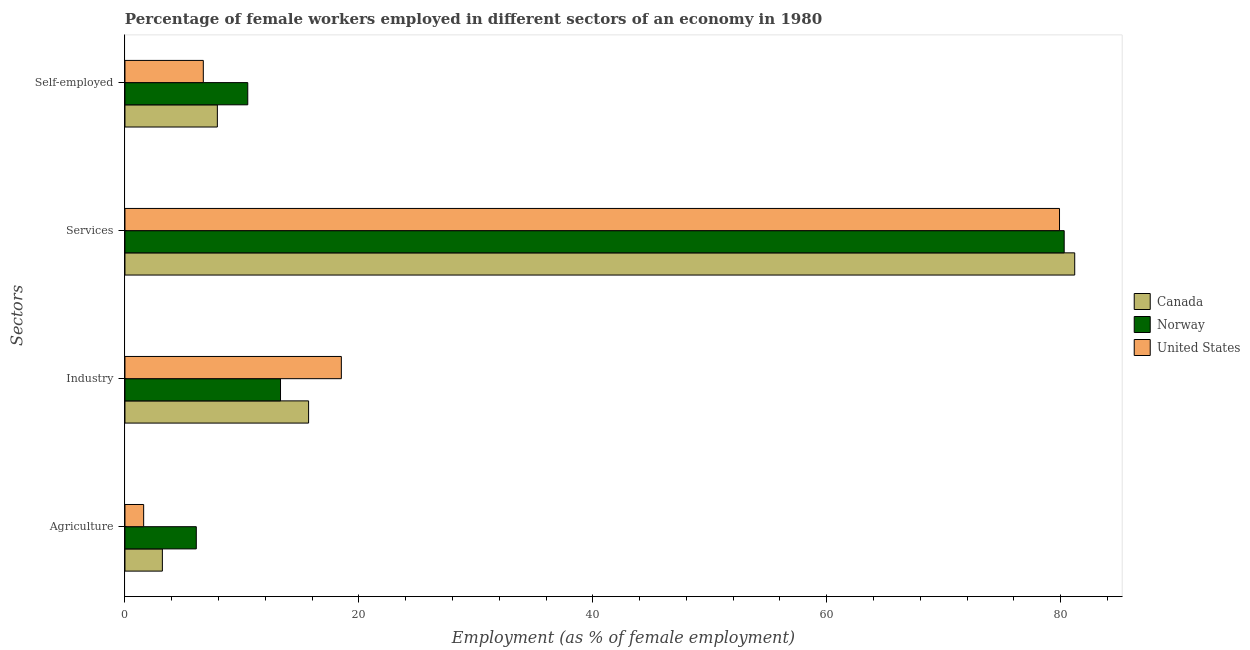How many groups of bars are there?
Offer a terse response. 4. Are the number of bars on each tick of the Y-axis equal?
Provide a short and direct response. Yes. How many bars are there on the 4th tick from the bottom?
Keep it short and to the point. 3. What is the label of the 1st group of bars from the top?
Your answer should be compact. Self-employed. What is the percentage of female workers in services in Canada?
Your response must be concise. 81.2. Across all countries, what is the minimum percentage of female workers in services?
Make the answer very short. 79.9. In which country was the percentage of female workers in industry minimum?
Give a very brief answer. Norway. What is the total percentage of female workers in services in the graph?
Your answer should be compact. 241.4. What is the difference between the percentage of female workers in industry in Canada and that in Norway?
Provide a short and direct response. 2.4. What is the difference between the percentage of self employed female workers in United States and the percentage of female workers in agriculture in Canada?
Offer a terse response. 3.5. What is the average percentage of female workers in industry per country?
Keep it short and to the point. 15.83. What is the difference between the percentage of female workers in industry and percentage of female workers in agriculture in Norway?
Keep it short and to the point. 7.2. In how many countries, is the percentage of female workers in services greater than 64 %?
Your answer should be compact. 3. What is the ratio of the percentage of self employed female workers in United States to that in Norway?
Keep it short and to the point. 0.64. Is the percentage of female workers in industry in Norway less than that in Canada?
Your answer should be compact. Yes. Is the difference between the percentage of female workers in services in United States and Canada greater than the difference between the percentage of female workers in industry in United States and Canada?
Offer a very short reply. No. What is the difference between the highest and the second highest percentage of female workers in agriculture?
Provide a succinct answer. 2.9. What is the difference between the highest and the lowest percentage of female workers in industry?
Make the answer very short. 5.2. What does the 2nd bar from the top in Services represents?
Provide a short and direct response. Norway. What does the 2nd bar from the bottom in Self-employed represents?
Your response must be concise. Norway. How many countries are there in the graph?
Give a very brief answer. 3. Are the values on the major ticks of X-axis written in scientific E-notation?
Offer a very short reply. No. How many legend labels are there?
Give a very brief answer. 3. How are the legend labels stacked?
Give a very brief answer. Vertical. What is the title of the graph?
Your answer should be compact. Percentage of female workers employed in different sectors of an economy in 1980. What is the label or title of the X-axis?
Provide a succinct answer. Employment (as % of female employment). What is the label or title of the Y-axis?
Make the answer very short. Sectors. What is the Employment (as % of female employment) in Canada in Agriculture?
Offer a very short reply. 3.2. What is the Employment (as % of female employment) of Norway in Agriculture?
Keep it short and to the point. 6.1. What is the Employment (as % of female employment) of United States in Agriculture?
Give a very brief answer. 1.6. What is the Employment (as % of female employment) in Canada in Industry?
Your answer should be compact. 15.7. What is the Employment (as % of female employment) of Norway in Industry?
Your response must be concise. 13.3. What is the Employment (as % of female employment) in Canada in Services?
Offer a very short reply. 81.2. What is the Employment (as % of female employment) of Norway in Services?
Keep it short and to the point. 80.3. What is the Employment (as % of female employment) of United States in Services?
Offer a very short reply. 79.9. What is the Employment (as % of female employment) in Canada in Self-employed?
Provide a short and direct response. 7.9. What is the Employment (as % of female employment) in United States in Self-employed?
Provide a succinct answer. 6.7. Across all Sectors, what is the maximum Employment (as % of female employment) of Canada?
Your response must be concise. 81.2. Across all Sectors, what is the maximum Employment (as % of female employment) of Norway?
Give a very brief answer. 80.3. Across all Sectors, what is the maximum Employment (as % of female employment) in United States?
Your answer should be compact. 79.9. Across all Sectors, what is the minimum Employment (as % of female employment) in Canada?
Make the answer very short. 3.2. Across all Sectors, what is the minimum Employment (as % of female employment) in Norway?
Keep it short and to the point. 6.1. Across all Sectors, what is the minimum Employment (as % of female employment) of United States?
Your answer should be compact. 1.6. What is the total Employment (as % of female employment) in Canada in the graph?
Ensure brevity in your answer.  108. What is the total Employment (as % of female employment) of Norway in the graph?
Offer a very short reply. 110.2. What is the total Employment (as % of female employment) in United States in the graph?
Provide a succinct answer. 106.7. What is the difference between the Employment (as % of female employment) in Canada in Agriculture and that in Industry?
Keep it short and to the point. -12.5. What is the difference between the Employment (as % of female employment) in Norway in Agriculture and that in Industry?
Provide a succinct answer. -7.2. What is the difference between the Employment (as % of female employment) of United States in Agriculture and that in Industry?
Offer a very short reply. -16.9. What is the difference between the Employment (as % of female employment) of Canada in Agriculture and that in Services?
Your response must be concise. -78. What is the difference between the Employment (as % of female employment) of Norway in Agriculture and that in Services?
Provide a short and direct response. -74.2. What is the difference between the Employment (as % of female employment) of United States in Agriculture and that in Services?
Keep it short and to the point. -78.3. What is the difference between the Employment (as % of female employment) in Norway in Agriculture and that in Self-employed?
Ensure brevity in your answer.  -4.4. What is the difference between the Employment (as % of female employment) in United States in Agriculture and that in Self-employed?
Keep it short and to the point. -5.1. What is the difference between the Employment (as % of female employment) of Canada in Industry and that in Services?
Provide a short and direct response. -65.5. What is the difference between the Employment (as % of female employment) of Norway in Industry and that in Services?
Make the answer very short. -67. What is the difference between the Employment (as % of female employment) of United States in Industry and that in Services?
Give a very brief answer. -61.4. What is the difference between the Employment (as % of female employment) of Canada in Industry and that in Self-employed?
Offer a terse response. 7.8. What is the difference between the Employment (as % of female employment) in Canada in Services and that in Self-employed?
Make the answer very short. 73.3. What is the difference between the Employment (as % of female employment) in Norway in Services and that in Self-employed?
Your answer should be compact. 69.8. What is the difference between the Employment (as % of female employment) in United States in Services and that in Self-employed?
Provide a short and direct response. 73.2. What is the difference between the Employment (as % of female employment) of Canada in Agriculture and the Employment (as % of female employment) of United States in Industry?
Give a very brief answer. -15.3. What is the difference between the Employment (as % of female employment) in Norway in Agriculture and the Employment (as % of female employment) in United States in Industry?
Your answer should be very brief. -12.4. What is the difference between the Employment (as % of female employment) in Canada in Agriculture and the Employment (as % of female employment) in Norway in Services?
Keep it short and to the point. -77.1. What is the difference between the Employment (as % of female employment) of Canada in Agriculture and the Employment (as % of female employment) of United States in Services?
Ensure brevity in your answer.  -76.7. What is the difference between the Employment (as % of female employment) in Norway in Agriculture and the Employment (as % of female employment) in United States in Services?
Your answer should be very brief. -73.8. What is the difference between the Employment (as % of female employment) in Canada in Agriculture and the Employment (as % of female employment) in Norway in Self-employed?
Offer a very short reply. -7.3. What is the difference between the Employment (as % of female employment) in Canada in Industry and the Employment (as % of female employment) in Norway in Services?
Offer a very short reply. -64.6. What is the difference between the Employment (as % of female employment) in Canada in Industry and the Employment (as % of female employment) in United States in Services?
Provide a short and direct response. -64.2. What is the difference between the Employment (as % of female employment) of Norway in Industry and the Employment (as % of female employment) of United States in Services?
Give a very brief answer. -66.6. What is the difference between the Employment (as % of female employment) in Norway in Industry and the Employment (as % of female employment) in United States in Self-employed?
Your answer should be very brief. 6.6. What is the difference between the Employment (as % of female employment) in Canada in Services and the Employment (as % of female employment) in Norway in Self-employed?
Offer a very short reply. 70.7. What is the difference between the Employment (as % of female employment) in Canada in Services and the Employment (as % of female employment) in United States in Self-employed?
Your answer should be compact. 74.5. What is the difference between the Employment (as % of female employment) of Norway in Services and the Employment (as % of female employment) of United States in Self-employed?
Give a very brief answer. 73.6. What is the average Employment (as % of female employment) of Norway per Sectors?
Your response must be concise. 27.55. What is the average Employment (as % of female employment) in United States per Sectors?
Your answer should be compact. 26.68. What is the difference between the Employment (as % of female employment) of Canada and Employment (as % of female employment) of Norway in Industry?
Keep it short and to the point. 2.4. What is the difference between the Employment (as % of female employment) in Canada and Employment (as % of female employment) in United States in Industry?
Offer a terse response. -2.8. What is the difference between the Employment (as % of female employment) in Canada and Employment (as % of female employment) in Norway in Services?
Your answer should be compact. 0.9. What is the difference between the Employment (as % of female employment) of Canada and Employment (as % of female employment) of United States in Services?
Make the answer very short. 1.3. What is the difference between the Employment (as % of female employment) of Canada and Employment (as % of female employment) of Norway in Self-employed?
Your response must be concise. -2.6. What is the difference between the Employment (as % of female employment) of Canada and Employment (as % of female employment) of United States in Self-employed?
Provide a succinct answer. 1.2. What is the difference between the Employment (as % of female employment) in Norway and Employment (as % of female employment) in United States in Self-employed?
Keep it short and to the point. 3.8. What is the ratio of the Employment (as % of female employment) in Canada in Agriculture to that in Industry?
Give a very brief answer. 0.2. What is the ratio of the Employment (as % of female employment) of Norway in Agriculture to that in Industry?
Provide a succinct answer. 0.46. What is the ratio of the Employment (as % of female employment) in United States in Agriculture to that in Industry?
Your response must be concise. 0.09. What is the ratio of the Employment (as % of female employment) in Canada in Agriculture to that in Services?
Keep it short and to the point. 0.04. What is the ratio of the Employment (as % of female employment) of Norway in Agriculture to that in Services?
Give a very brief answer. 0.08. What is the ratio of the Employment (as % of female employment) in Canada in Agriculture to that in Self-employed?
Your answer should be very brief. 0.41. What is the ratio of the Employment (as % of female employment) of Norway in Agriculture to that in Self-employed?
Provide a succinct answer. 0.58. What is the ratio of the Employment (as % of female employment) in United States in Agriculture to that in Self-employed?
Offer a terse response. 0.24. What is the ratio of the Employment (as % of female employment) of Canada in Industry to that in Services?
Your answer should be compact. 0.19. What is the ratio of the Employment (as % of female employment) of Norway in Industry to that in Services?
Make the answer very short. 0.17. What is the ratio of the Employment (as % of female employment) of United States in Industry to that in Services?
Your response must be concise. 0.23. What is the ratio of the Employment (as % of female employment) in Canada in Industry to that in Self-employed?
Offer a terse response. 1.99. What is the ratio of the Employment (as % of female employment) of Norway in Industry to that in Self-employed?
Give a very brief answer. 1.27. What is the ratio of the Employment (as % of female employment) of United States in Industry to that in Self-employed?
Make the answer very short. 2.76. What is the ratio of the Employment (as % of female employment) in Canada in Services to that in Self-employed?
Give a very brief answer. 10.28. What is the ratio of the Employment (as % of female employment) of Norway in Services to that in Self-employed?
Your answer should be very brief. 7.65. What is the ratio of the Employment (as % of female employment) of United States in Services to that in Self-employed?
Give a very brief answer. 11.93. What is the difference between the highest and the second highest Employment (as % of female employment) of Canada?
Offer a terse response. 65.5. What is the difference between the highest and the second highest Employment (as % of female employment) of United States?
Offer a very short reply. 61.4. What is the difference between the highest and the lowest Employment (as % of female employment) in Norway?
Your answer should be very brief. 74.2. What is the difference between the highest and the lowest Employment (as % of female employment) in United States?
Your response must be concise. 78.3. 